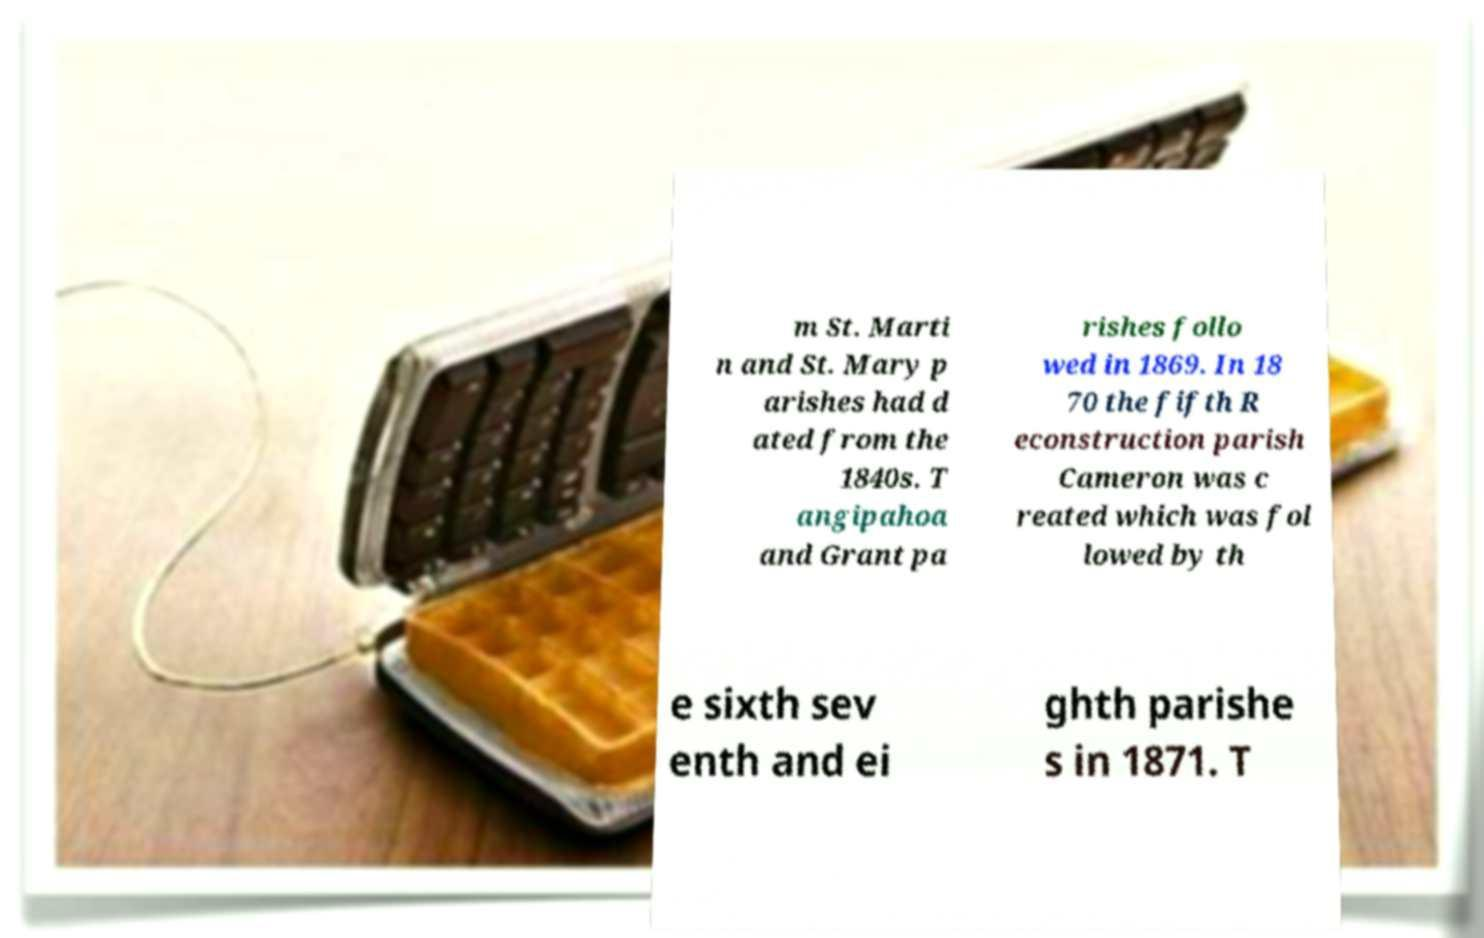Can you read and provide the text displayed in the image?This photo seems to have some interesting text. Can you extract and type it out for me? m St. Marti n and St. Mary p arishes had d ated from the 1840s. T angipahoa and Grant pa rishes follo wed in 1869. In 18 70 the fifth R econstruction parish Cameron was c reated which was fol lowed by th e sixth sev enth and ei ghth parishe s in 1871. T 